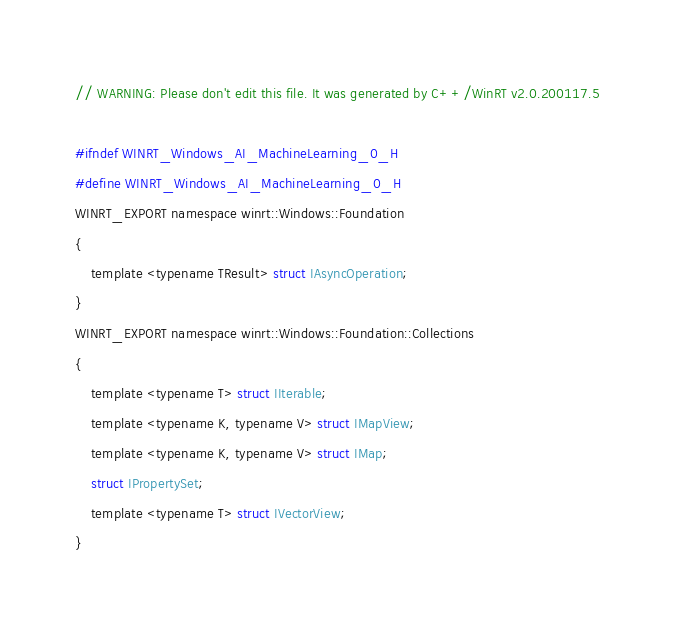Convert code to text. <code><loc_0><loc_0><loc_500><loc_500><_C_>// WARNING: Please don't edit this file. It was generated by C++/WinRT v2.0.200117.5

#ifndef WINRT_Windows_AI_MachineLearning_0_H
#define WINRT_Windows_AI_MachineLearning_0_H
WINRT_EXPORT namespace winrt::Windows::Foundation
{
    template <typename TResult> struct IAsyncOperation;
}
WINRT_EXPORT namespace winrt::Windows::Foundation::Collections
{
    template <typename T> struct IIterable;
    template <typename K, typename V> struct IMapView;
    template <typename K, typename V> struct IMap;
    struct IPropertySet;
    template <typename T> struct IVectorView;
}</code> 